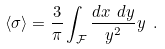Convert formula to latex. <formula><loc_0><loc_0><loc_500><loc_500>\langle \sigma \rangle = \frac { 3 } { \pi } \int _ { \mathcal { F } } \frac { d x \ d y } { y ^ { 2 } } y \ .</formula> 